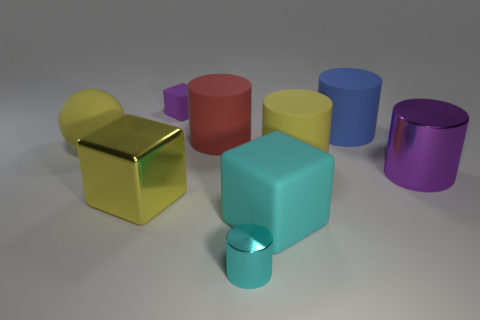Subtract all big yellow cubes. How many cubes are left? 2 Subtract all cyan cylinders. How many cylinders are left? 4 Subtract all cubes. How many objects are left? 6 Subtract 3 cubes. How many cubes are left? 0 Subtract all red cylinders. How many purple cubes are left? 1 Subtract all big brown matte cubes. Subtract all big red things. How many objects are left? 8 Add 3 big shiny blocks. How many big shiny blocks are left? 4 Add 5 brown rubber spheres. How many brown rubber spheres exist? 5 Subtract 1 cyan cylinders. How many objects are left? 8 Subtract all green cylinders. Subtract all brown spheres. How many cylinders are left? 5 